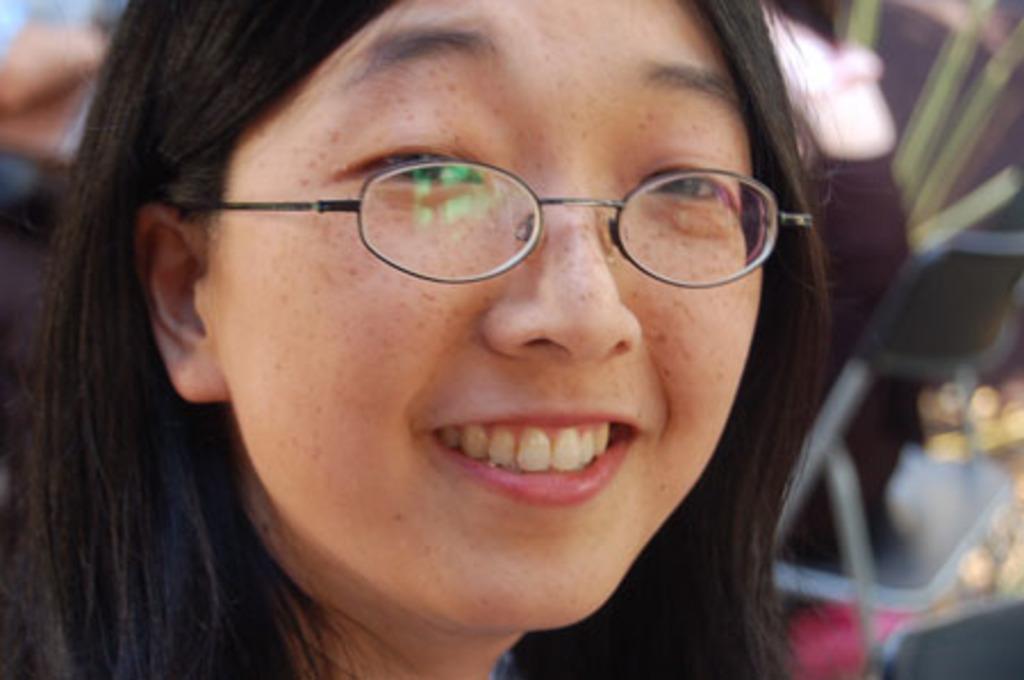Please provide a concise description of this image. In this image I can see there is a woman, she has spectacles and the background of the image is blurred. 